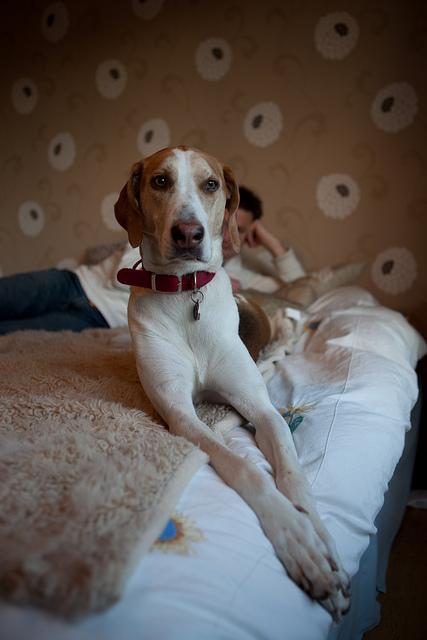What is the dog laying on?
Answer briefly. Bed. Is the dog laying on a bed?
Be succinct. Yes. Is that a fireplace in the background?
Concise answer only. No. Is a paw tucked in?
Be succinct. No. What color are the sheets?
Give a very brief answer. White. What color is the dog's collar?
Write a very short answer. Red. Where IS THIS DOG?
Write a very short answer. Bed. What color is the dog's nose?
Keep it brief. Brown. Is the dog wearing a tie?
Give a very brief answer. No. Is the dog brown?
Quick response, please. No. Is there a woman or a man behind the dog?
Quick response, please. Man. What color is the dog?
Answer briefly. White and brown. 